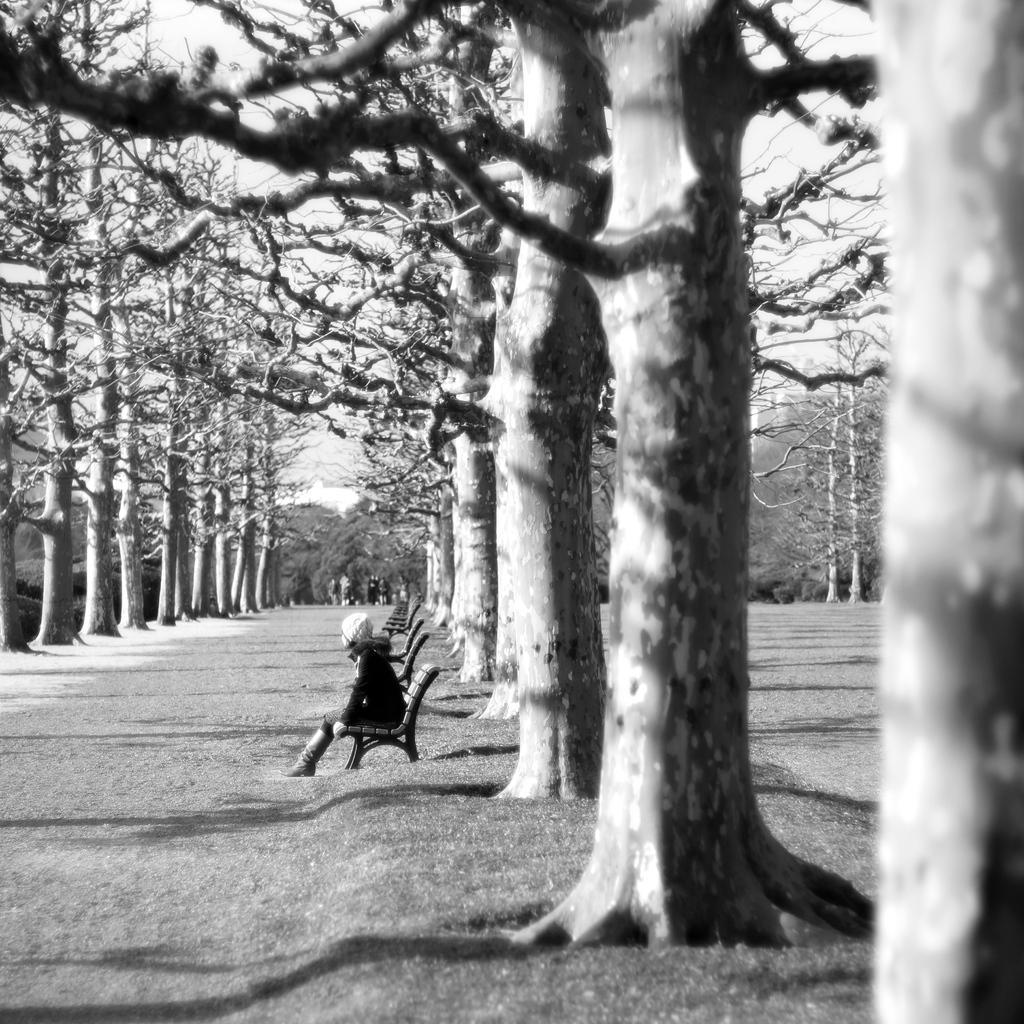Describe this image in one or two sentences. It is the black and white image in which there is a path in the middle and there are tall trees on either side of the path. Beside the trees there are benches in the line. There is a girl sitting on the bench. 